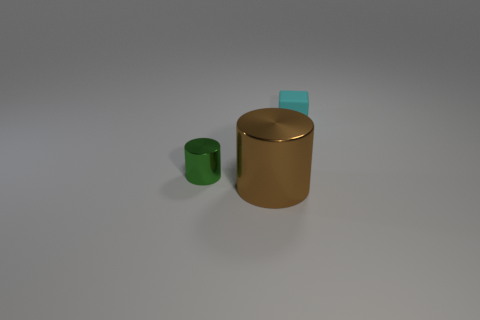Add 3 large brown shiny cylinders. How many objects exist? 6 Subtract all green cylinders. How many cylinders are left? 1 Subtract all cylinders. How many objects are left? 1 Subtract 1 cylinders. How many cylinders are left? 1 Subtract all yellow cylinders. Subtract all green blocks. How many cylinders are left? 2 Subtract all big shiny spheres. Subtract all big brown metal objects. How many objects are left? 2 Add 2 cyan matte objects. How many cyan matte objects are left? 3 Add 2 cubes. How many cubes exist? 3 Subtract 1 cyan blocks. How many objects are left? 2 